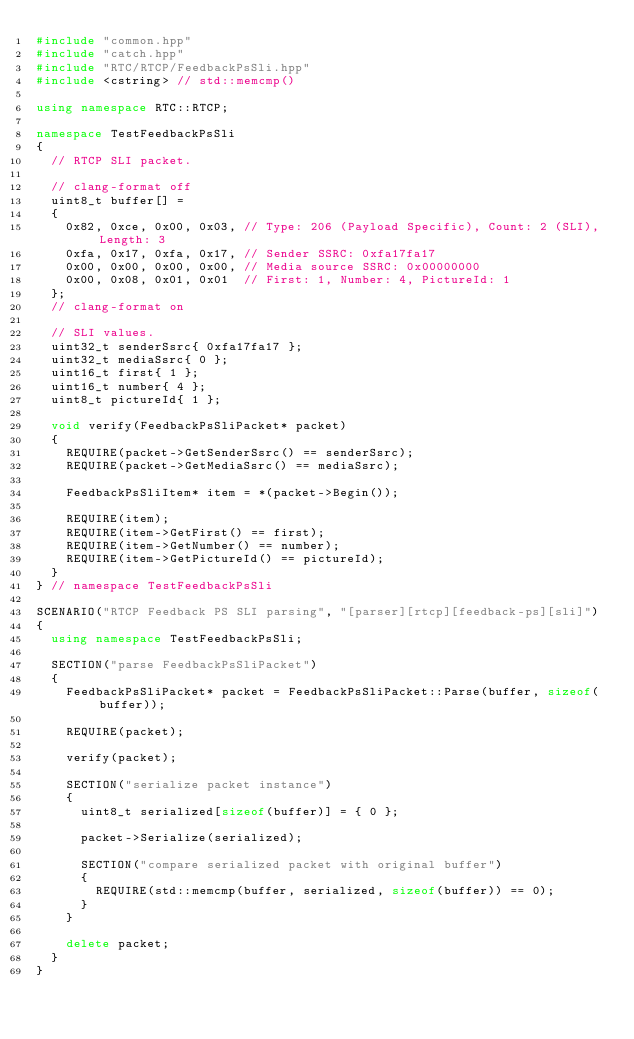<code> <loc_0><loc_0><loc_500><loc_500><_C++_>#include "common.hpp"
#include "catch.hpp"
#include "RTC/RTCP/FeedbackPsSli.hpp"
#include <cstring> // std::memcmp()

using namespace RTC::RTCP;

namespace TestFeedbackPsSli
{
	// RTCP SLI packet.

	// clang-format off
	uint8_t buffer[] =
	{
		0x82, 0xce, 0x00, 0x03, // Type: 206 (Payload Specific), Count: 2 (SLI), Length: 3
		0xfa, 0x17, 0xfa, 0x17, // Sender SSRC: 0xfa17fa17
		0x00, 0x00, 0x00, 0x00, // Media source SSRC: 0x00000000
		0x00, 0x08, 0x01, 0x01  // First: 1, Number: 4, PictureId: 1
	};
	// clang-format on

	// SLI values.
	uint32_t senderSsrc{ 0xfa17fa17 };
	uint32_t mediaSsrc{ 0 };
	uint16_t first{ 1 };
	uint16_t number{ 4 };
	uint8_t pictureId{ 1 };

	void verify(FeedbackPsSliPacket* packet)
	{
		REQUIRE(packet->GetSenderSsrc() == senderSsrc);
		REQUIRE(packet->GetMediaSsrc() == mediaSsrc);

		FeedbackPsSliItem* item = *(packet->Begin());

		REQUIRE(item);
		REQUIRE(item->GetFirst() == first);
		REQUIRE(item->GetNumber() == number);
		REQUIRE(item->GetPictureId() == pictureId);
	}
} // namespace TestFeedbackPsSli

SCENARIO("RTCP Feedback PS SLI parsing", "[parser][rtcp][feedback-ps][sli]")
{
	using namespace TestFeedbackPsSli;

	SECTION("parse FeedbackPsSliPacket")
	{
		FeedbackPsSliPacket* packet = FeedbackPsSliPacket::Parse(buffer, sizeof(buffer));

		REQUIRE(packet);

		verify(packet);

		SECTION("serialize packet instance")
		{
			uint8_t serialized[sizeof(buffer)] = { 0 };

			packet->Serialize(serialized);

			SECTION("compare serialized packet with original buffer")
			{
				REQUIRE(std::memcmp(buffer, serialized, sizeof(buffer)) == 0);
			}
		}

		delete packet;
	}
}
</code> 